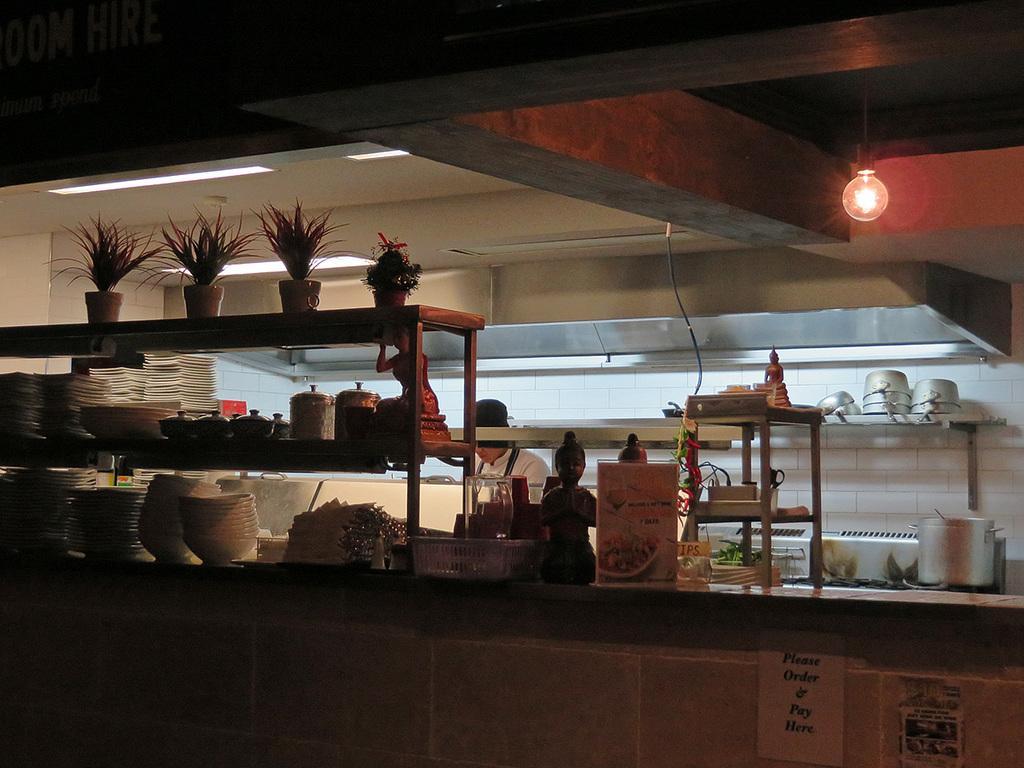Please provide a concise description of this image. This picture shows an inner view of a kitchen. We see few vessels and a man standing and he wore a cap on his head and we see few clothes and plants in the pots and few bowls and a statue and we see a paper board and a rack on the side and we see light hanging to the ceiling and we see few roof ceiling lights. 